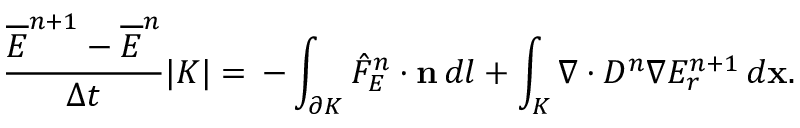<formula> <loc_0><loc_0><loc_500><loc_500>\frac { \overline { E } ^ { n + 1 } - \overline { E } ^ { n } } { \Delta t } | K | = \, - \int _ { \partial K } \hat { F } _ { E } ^ { n } \cdot n \, d l + \int _ { K } \nabla \cdot D ^ { n } \nabla E _ { r } ^ { n + 1 } \, d x .</formula> 